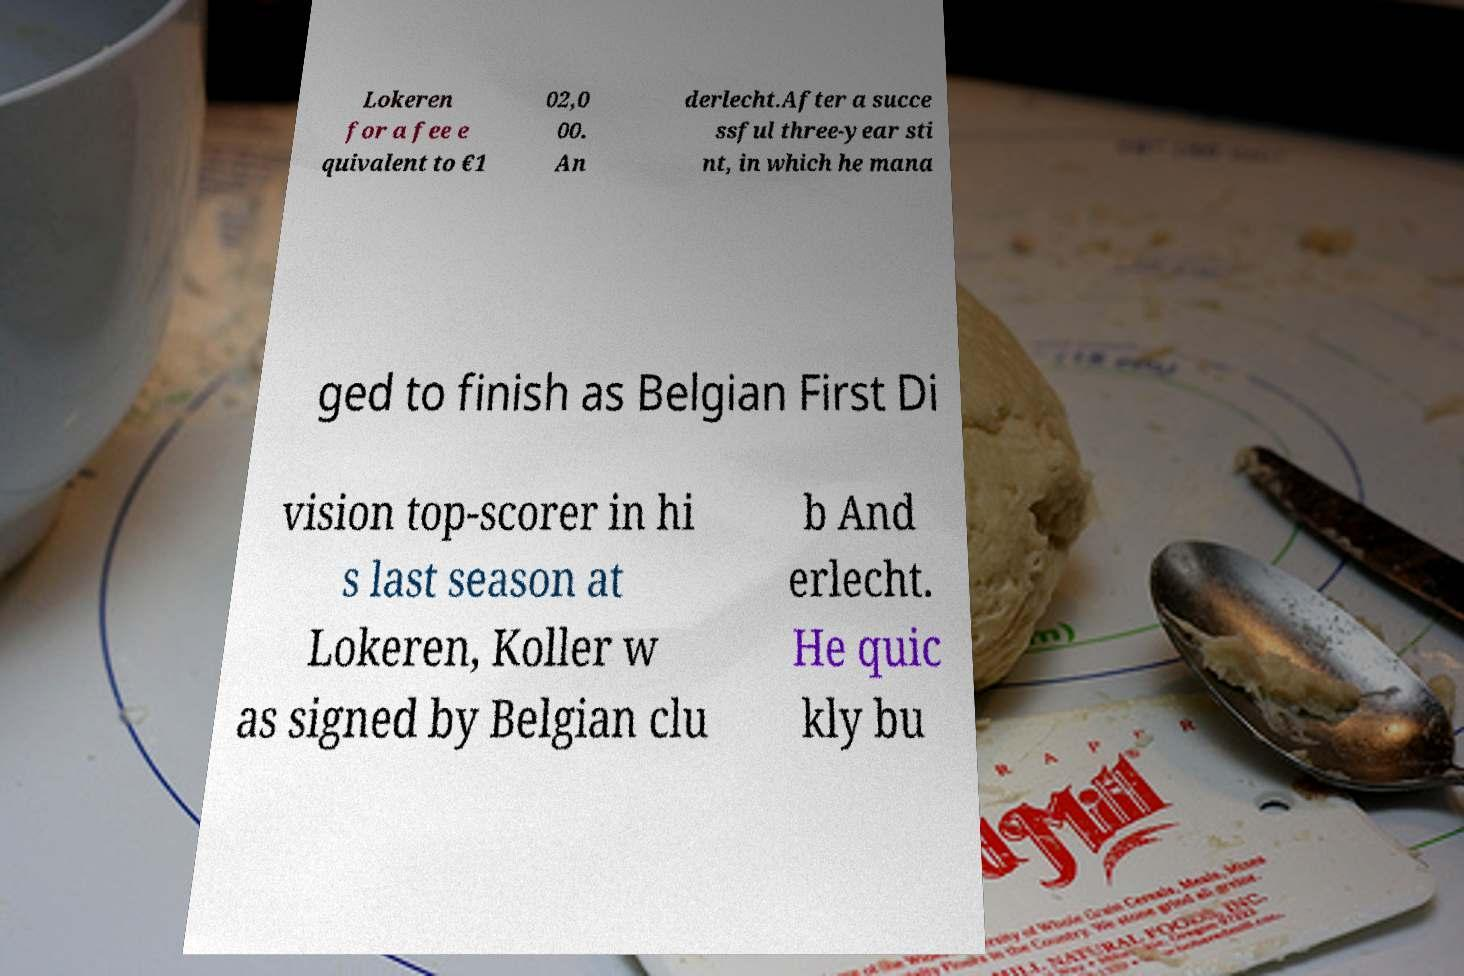Can you read and provide the text displayed in the image?This photo seems to have some interesting text. Can you extract and type it out for me? Lokeren for a fee e quivalent to €1 02,0 00. An derlecht.After a succe ssful three-year sti nt, in which he mana ged to finish as Belgian First Di vision top-scorer in hi s last season at Lokeren, Koller w as signed by Belgian clu b And erlecht. He quic kly bu 